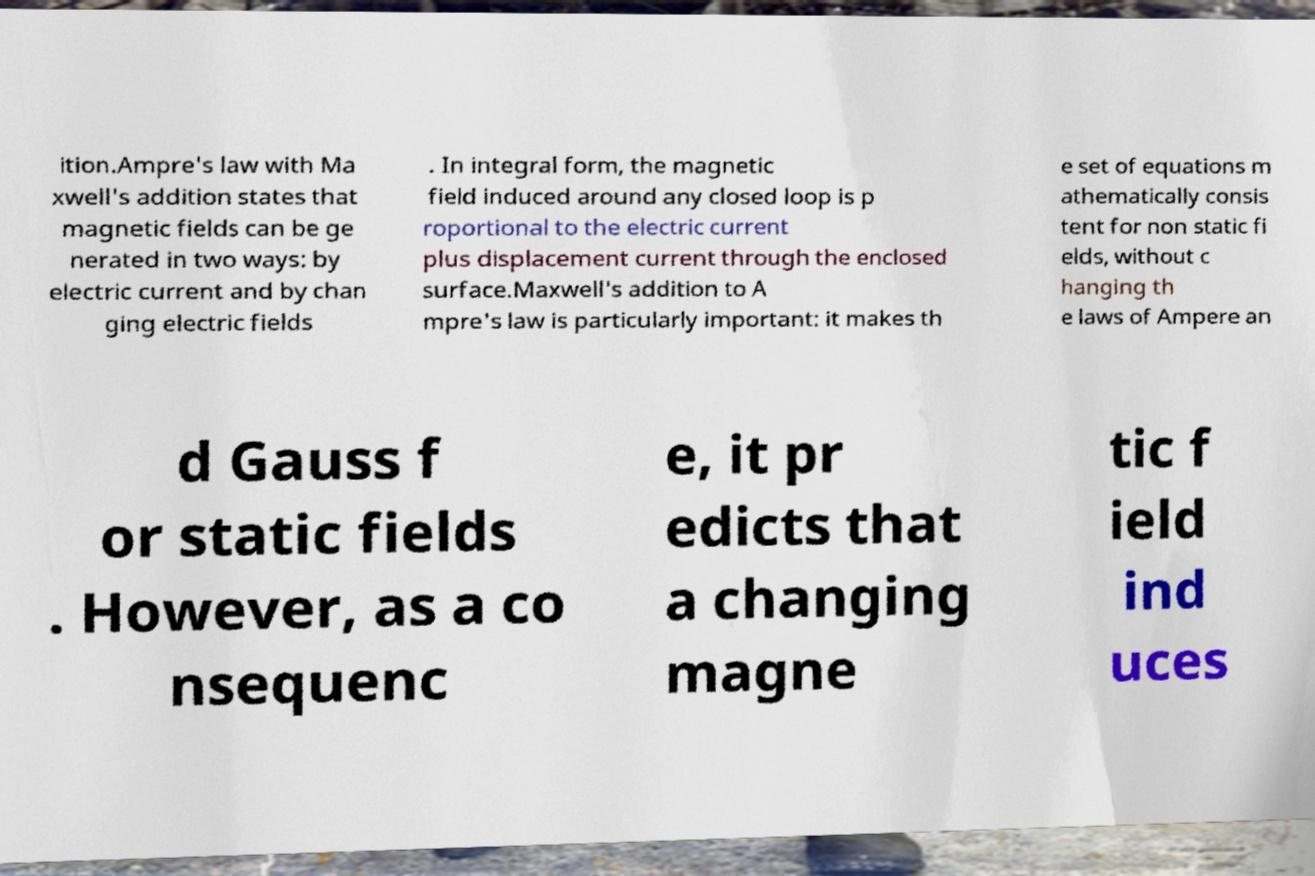What messages or text are displayed in this image? I need them in a readable, typed format. ition.Ampre's law with Ma xwell's addition states that magnetic fields can be ge nerated in two ways: by electric current and by chan ging electric fields . In integral form, the magnetic field induced around any closed loop is p roportional to the electric current plus displacement current through the enclosed surface.Maxwell's addition to A mpre's law is particularly important: it makes th e set of equations m athematically consis tent for non static fi elds, without c hanging th e laws of Ampere an d Gauss f or static fields . However, as a co nsequenc e, it pr edicts that a changing magne tic f ield ind uces 